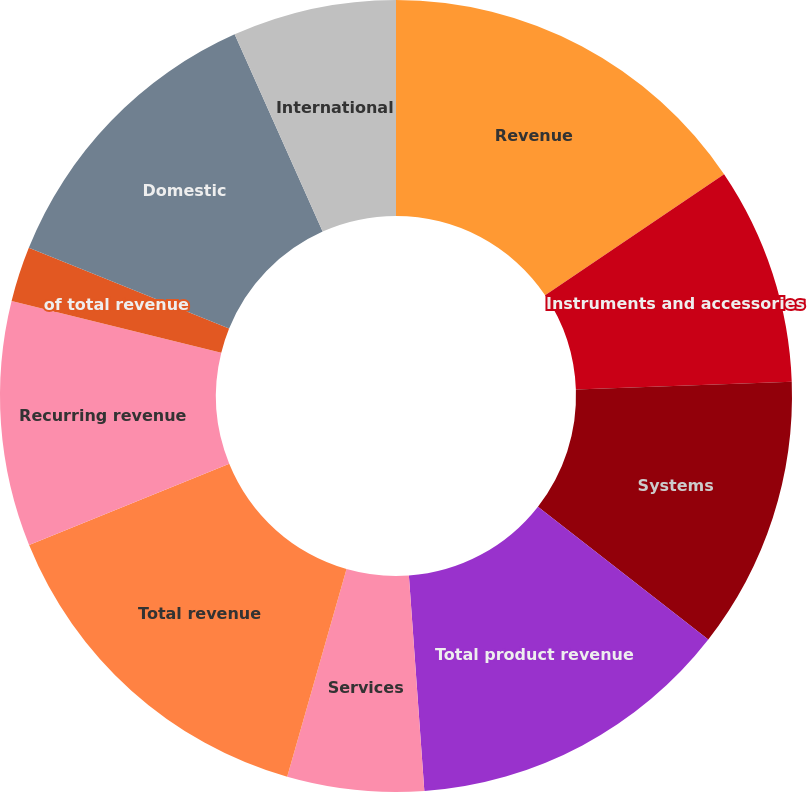Convert chart to OTSL. <chart><loc_0><loc_0><loc_500><loc_500><pie_chart><fcel>Revenue<fcel>Instruments and accessories<fcel>Systems<fcel>Total product revenue<fcel>Services<fcel>Total revenue<fcel>Recurring revenue<fcel>of total revenue<fcel>Domestic<fcel>International<nl><fcel>15.54%<fcel>8.89%<fcel>11.11%<fcel>13.32%<fcel>5.57%<fcel>14.43%<fcel>10.0%<fcel>2.25%<fcel>12.21%<fcel>6.68%<nl></chart> 